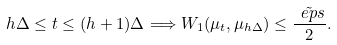<formula> <loc_0><loc_0><loc_500><loc_500>h \Delta \leq t \leq ( h + 1 ) \Delta \Longrightarrow W _ { 1 } ( \mu _ { t } , \mu _ { h \Delta } ) \leq \frac { \tilde { \ e p s } } { 2 } .</formula> 